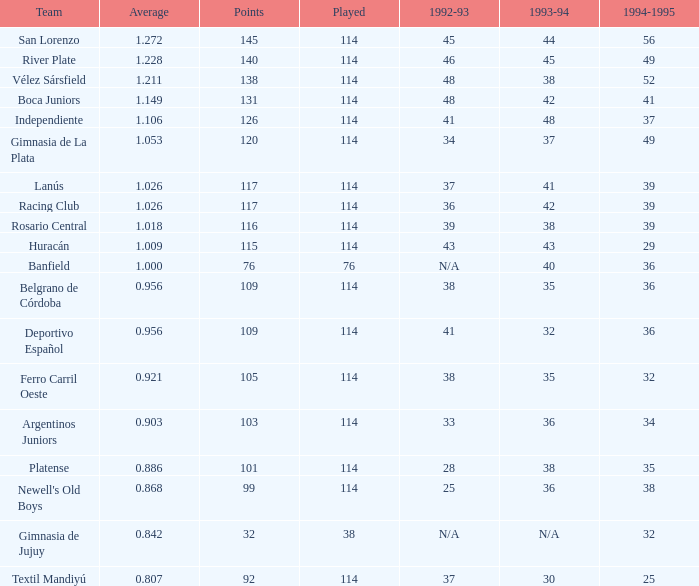Name the team for 1993-94 for 32 Deportivo Español. 